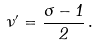Convert formula to latex. <formula><loc_0><loc_0><loc_500><loc_500>\nu ^ { \prime } = \frac { \sigma - 1 } { 2 } \, .</formula> 